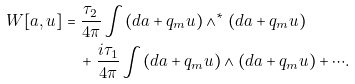Convert formula to latex. <formula><loc_0><loc_0><loc_500><loc_500>W [ a , u ] & = \frac { \tau _ { 2 } } { 4 \pi } \int ( d a + q _ { m } u ) \wedge ^ { * } ( d a + q _ { m } u ) \\ & \quad + \frac { i \tau _ { 1 } } { 4 \pi } \int ( d a + q _ { m } u ) \wedge ( d a + q _ { m } u ) + \cdots .</formula> 